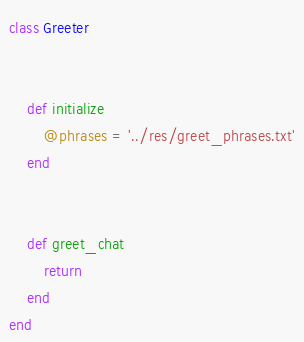<code> <loc_0><loc_0><loc_500><loc_500><_Ruby_>

class Greeter

    
    def initialize
        @phrases = '../res/greet_phrases.txt'
    end


    def greet_chat
        return 
    end
end</code> 